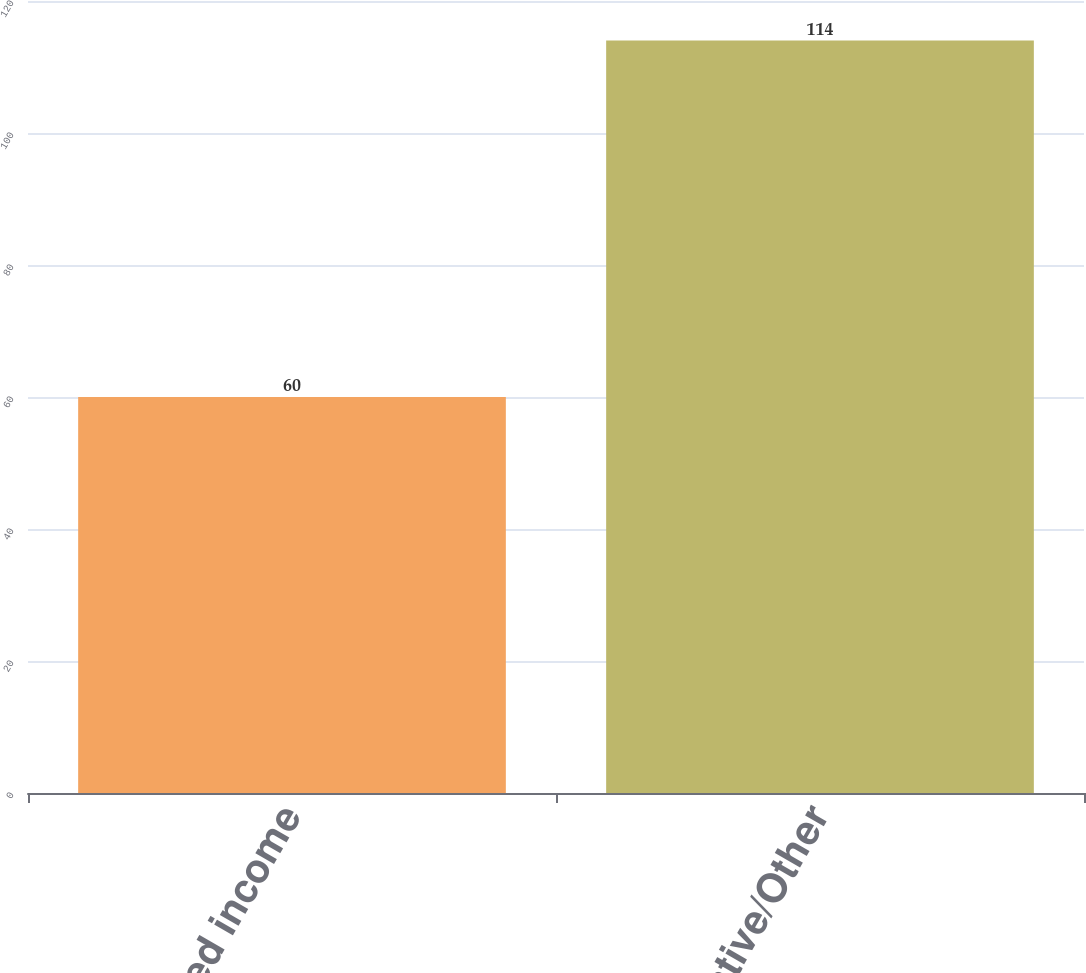<chart> <loc_0><loc_0><loc_500><loc_500><bar_chart><fcel>Fixed income<fcel>Alternative/Other<nl><fcel>60<fcel>114<nl></chart> 